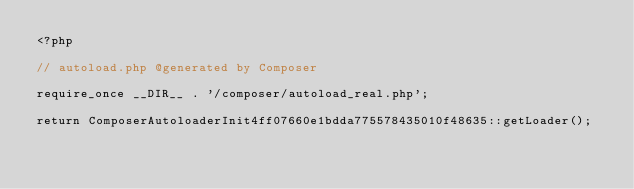<code> <loc_0><loc_0><loc_500><loc_500><_PHP_><?php

// autoload.php @generated by Composer

require_once __DIR__ . '/composer/autoload_real.php';

return ComposerAutoloaderInit4ff07660e1bdda775578435010f48635::getLoader();
</code> 